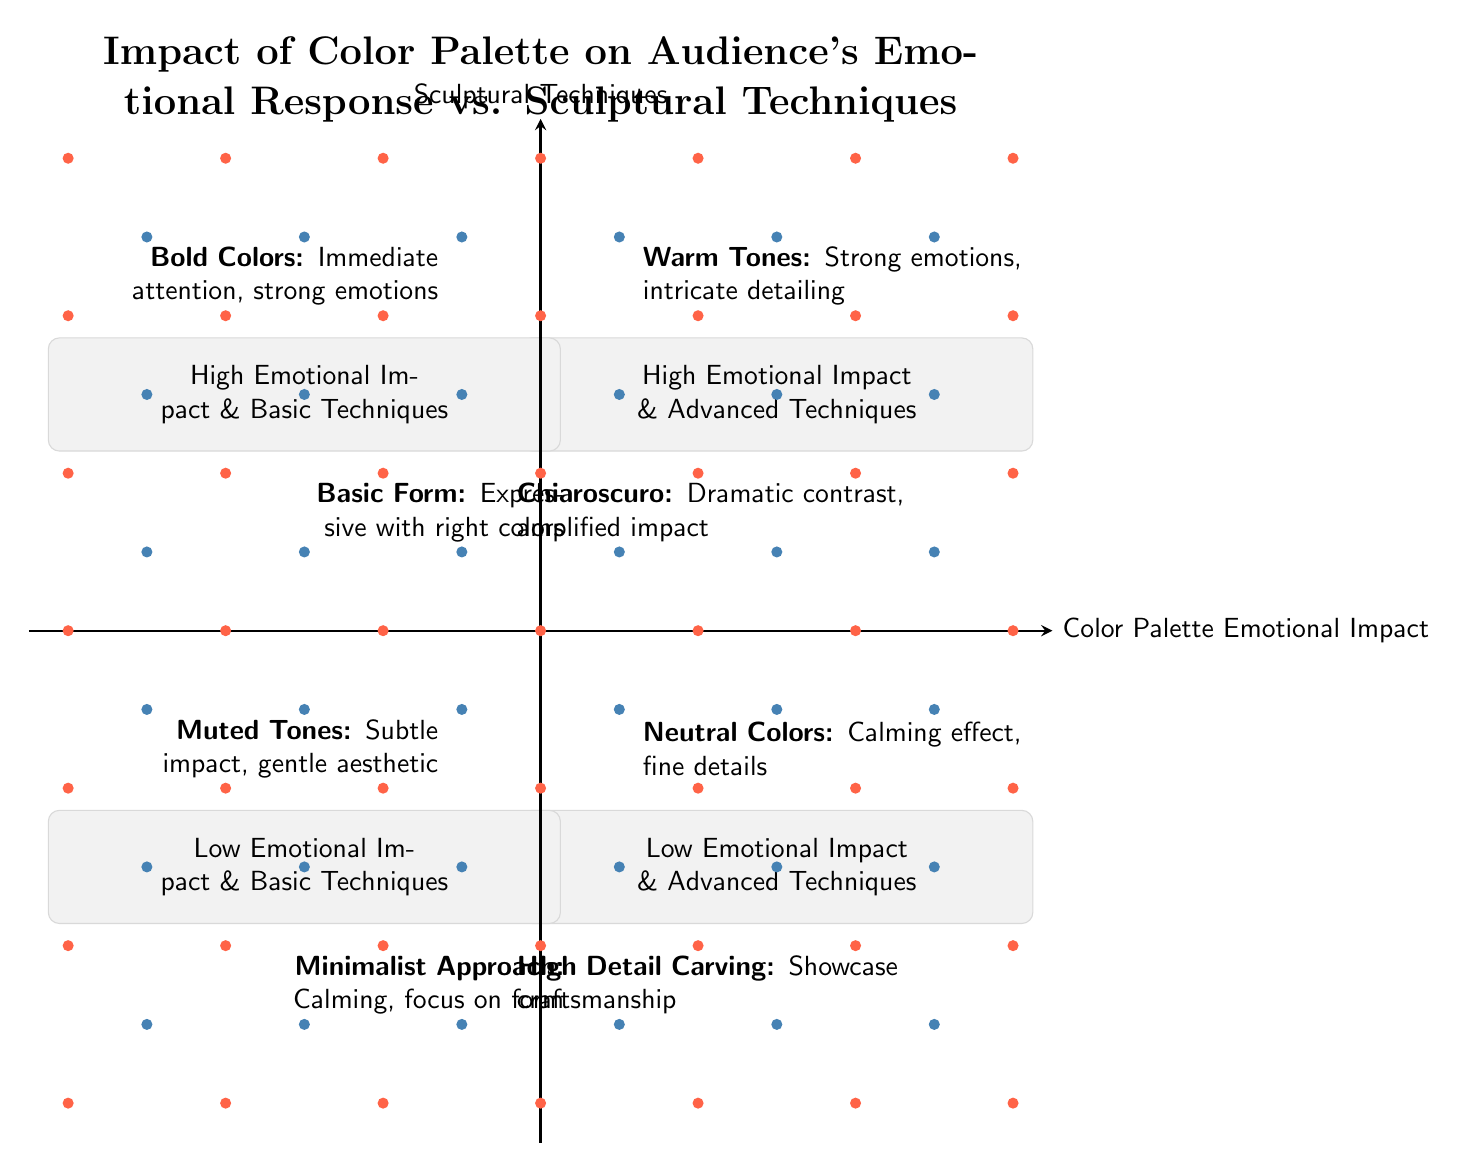What occupies the top right quadrant? The top right quadrant is labeled "High Emotional Impact & Advanced Techniques" and contains elements like Warm Tones and Chiaroscuro.
Answer: High Emotional Impact & Advanced Techniques How many elements are in the bottom left quadrant? The bottom left quadrant is labeled "Low Emotional Impact & Basic Techniques" and contains two elements: Muted Tones and Minimalist Approach.
Answer: 2 What are the two elements in the top left quadrant? The top left quadrant is labeled "High Emotional Impact & Basic Techniques"; its elements are Bold Colors and Basic Form.
Answer: Bold Colors, Basic Form Which element has a calming effect according to the diagram? Neutral Colors are described in the bottom right quadrant as having a calming effect.
Answer: Neutral Colors What is the relationship between advanced techniques and emotional impact in the top right quadrant? In the top right quadrant, the elements exhibit both advanced sculptural techniques (like Chiaroscuro) and high emotional impact, suggesting a correlation between complexity and emotional resonance.
Answer: High Emotional Impact & Advanced Techniques Which quadrant contains the element "Muted Tones"? The element "Muted Tones" is located in the bottom left quadrant, which is labeled "Low Emotional Impact & Basic Techniques".
Answer: Low Emotional Impact & Basic Techniques Which two color palettes evoke strong emotions according to the quadrants? In the top left quadrant, Bold Colors can evoke strong emotions, while Warm Tones in the top right quadrant also evoke strong emotions.
Answer: Bold Colors, Warm Tones What sculptural technique is paired with high detail carving? The bottom right quadrant discusses High Detail Carving paired with Neutral Colors. Thus, High Detail Carving is the technique associated with neutral colors.
Answer: High Detail Carving What is the common characteristic of elements in the bottom left quadrant? Elements in the bottom left quadrant, which include Muted Tones and Minimalist Approach, share the common characteristic of low emotional impact.
Answer: Low Emotional Impact 